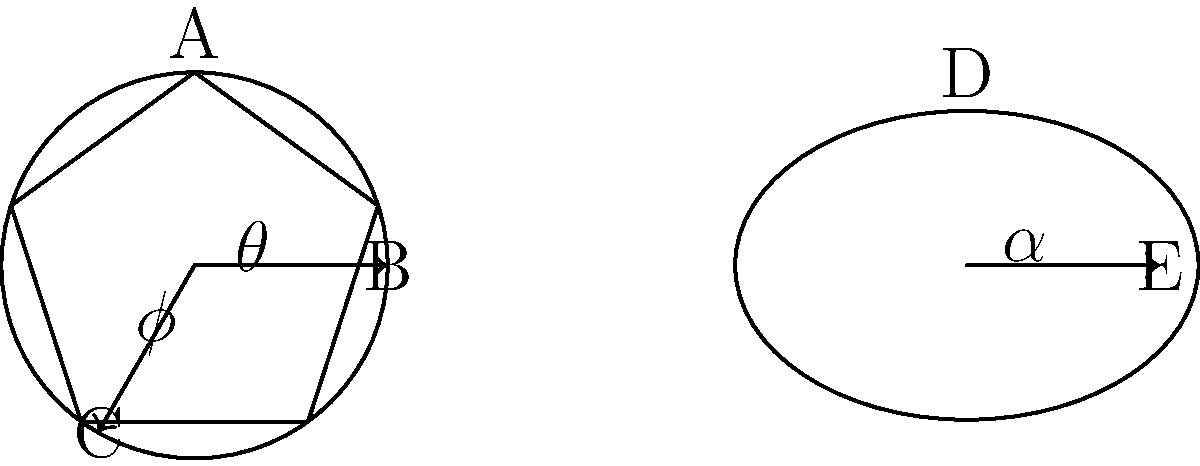In a contemporary adaptation of Greek mythology, you're designing masks for three characters: a circular mask for Apollo, a pentagonal mask for Athena, and an elliptical mask for Dionysus. Given that angle $\theta$ in Apollo's mask is 72°, angle $\phi$ in Athena's mask is 108°, and angle $\alpha$ in Dionysus' mask is 30°, what is the sum of the complementary angles to $\theta$, $\phi$, and $\alpha$? Let's approach this step-by-step:

1) First, recall that complementary angles are two angles that add up to 90°.

2) For Apollo's circular mask:
   Complementary angle to $\theta = 90° - 72° = 18°$

3) For Athena's pentagonal mask:
   Complementary angle to $\phi = 90° - 108° = -18°$
   Note: Since 108° is greater than 90°, its complement is negative.

4) For Dionysus' elliptical mask:
   Complementary angle to $\alpha = 90° - 30° = 60°$

5) Now, we sum these complementary angles:
   $18° + (-18°) + 60° = 60°$

Therefore, the sum of the complementary angles is 60°.
Answer: 60° 